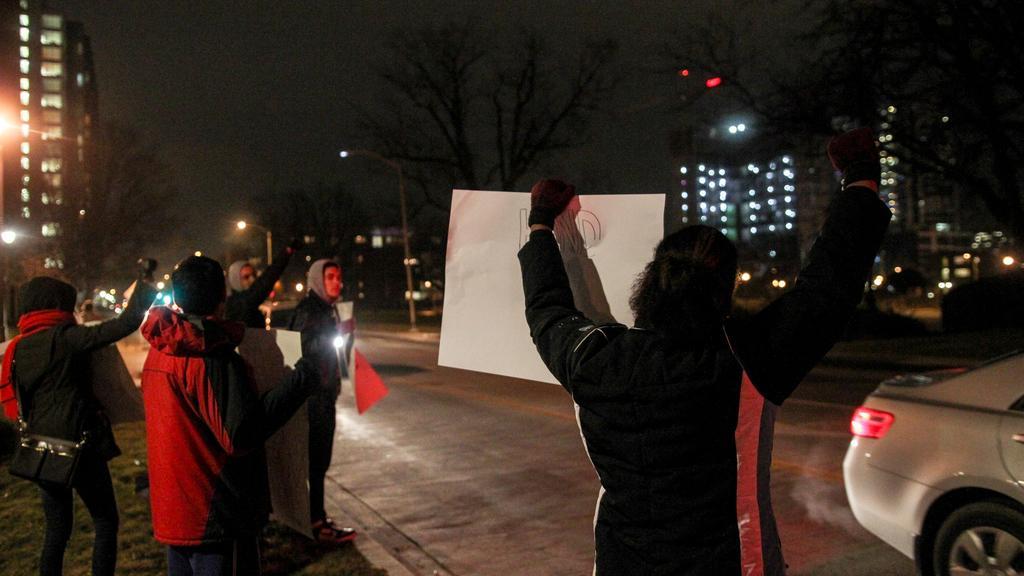In one or two sentences, can you explain what this image depicts? In this image we can see a few buildings, street lights and many trees in the image. A group of people are standing and holding someone objects at the right most of the image. 